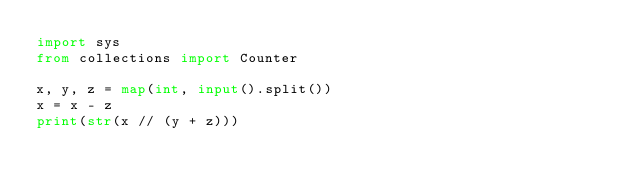Convert code to text. <code><loc_0><loc_0><loc_500><loc_500><_Python_>import sys
from collections import Counter

x, y, z = map(int, input().split())
x = x - z
print(str(x // (y + z)))
</code> 